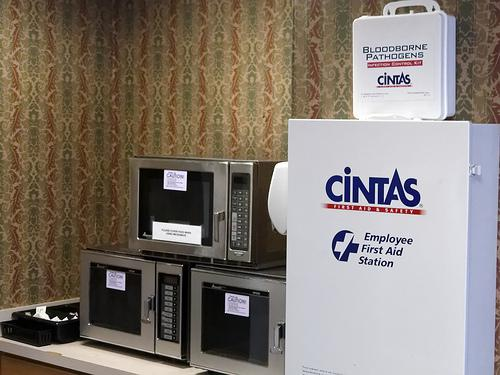Question: what is on the top microwave?
Choices:
A. A cell phone.
B. A banana.
C. House keys.
D. A typed note.
Answer with the letter. Answer: D Question: what is the brand of the first aid station?
Choices:
A. Red Cross.
B. Signa.
C. Johnson and Johnson.
D. CINTAS.
Answer with the letter. Answer: D Question: how are the microwaves arranged?
Choices:
A. Side by side.
B. Stacked.
C. In a row.
D. In a pyramid.
Answer with the letter. Answer: D Question: where is the smaller white box?
Choices:
A. Next to the white box.
B. Under the blue box.
C. On top of the large white box.
D. On the bottom of the pile.
Answer with the letter. Answer: C Question: what are the first two lines of text on the small white box?
Choices:
A. Radioactive Materials.
B. Caution Biohazard.
C. Bloodborne Pathogens.
D. Blood Products.
Answer with the letter. Answer: C 